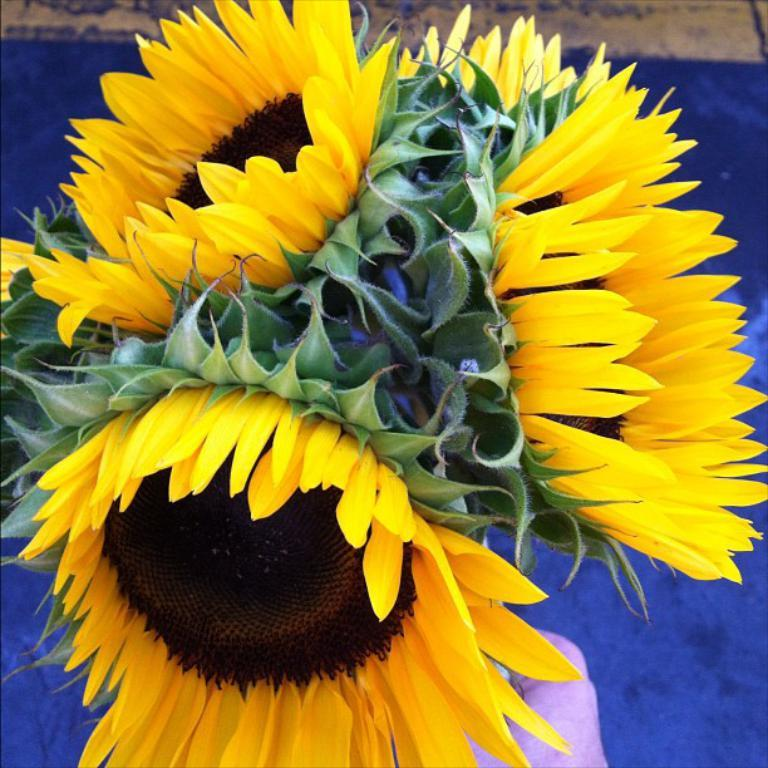What type of flowers can be seen in the image? There are yellow flowers in the image. What color is the carpet that is on the ground in the image? The carpet is blue. Where is the kettle located in the image? There is no kettle present in the image. What type of muscle can be seen in the image? There are no muscles visible in the image; it features yellow flowers and a blue carpet. 